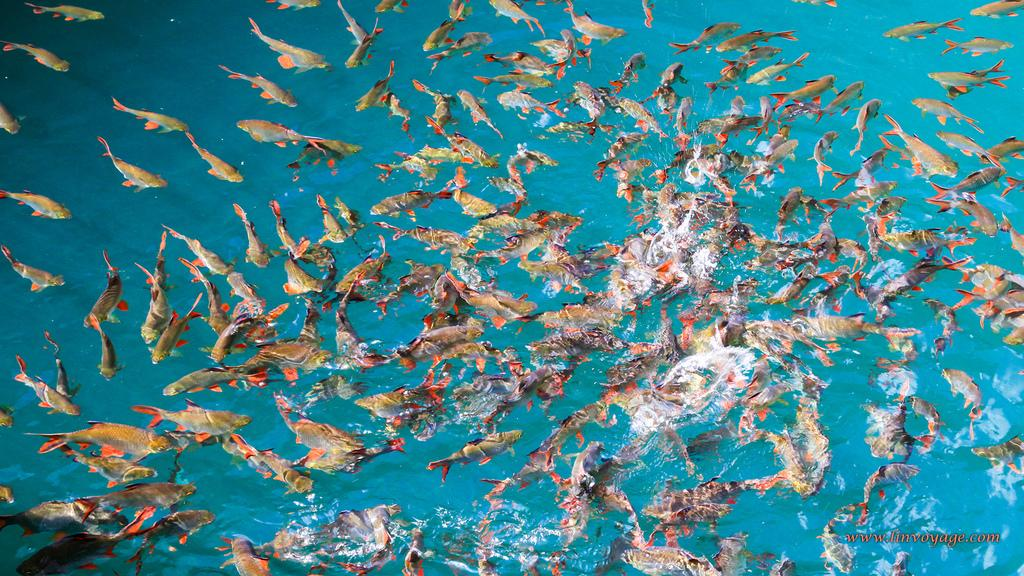What type of animals can be seen in the image? There is a group of fish in the image. What is the primary element in which the fish are situated? The fish are situated in water, which is visible in the image. Is there any text present in the image? Yes, there is some text in the bottom right corner of the image. What type of screw can be seen holding the queen's crown in the image? There is no screw or queen present in the image; it features a group of fish in water with some text in the bottom right corner. 